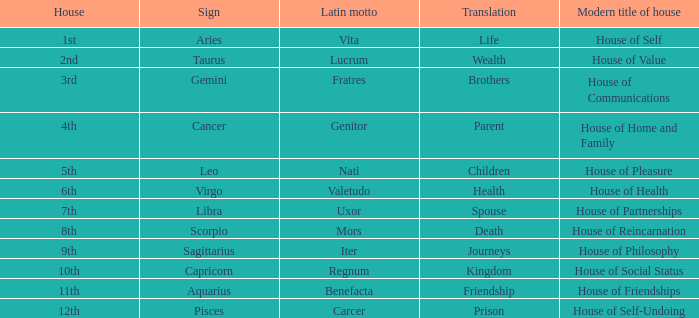Which modern house title translates to prison? House of Self-Undoing. 